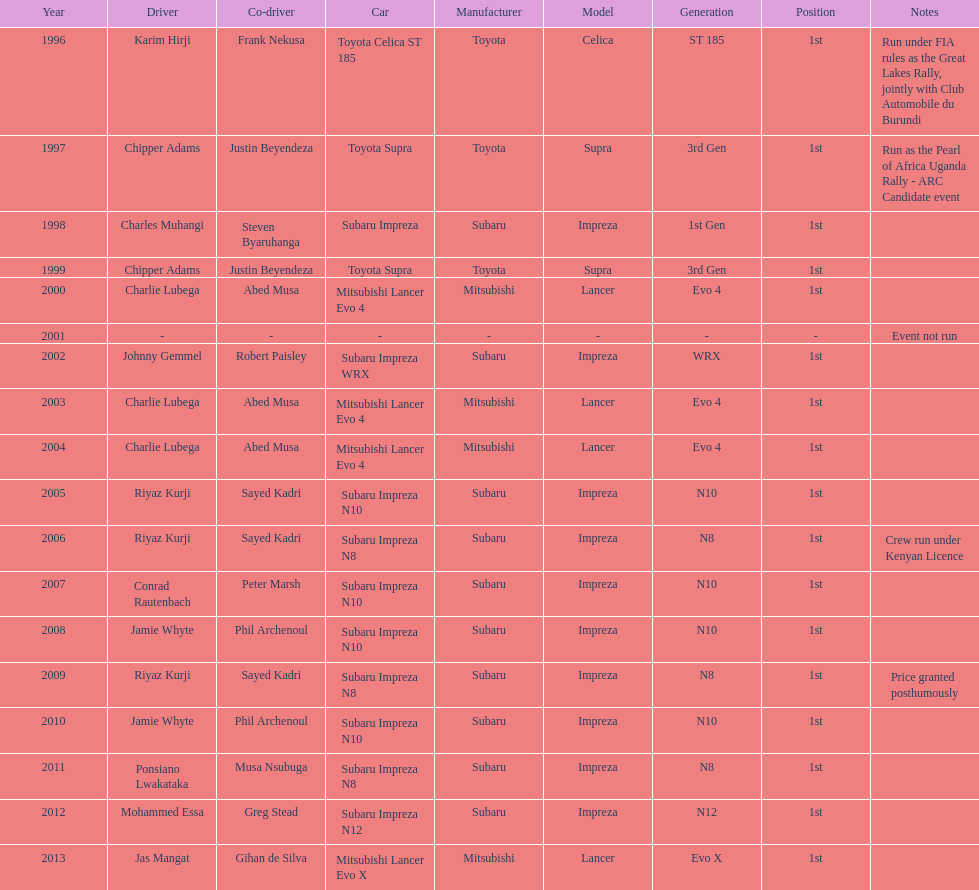Can you parse all the data within this table? {'header': ['Year', 'Driver', 'Co-driver', 'Car', 'Manufacturer', 'Model', 'Generation', 'Position', 'Notes'], 'rows': [['1996', 'Karim Hirji', 'Frank Nekusa', 'Toyota Celica ST 185', 'Toyota', 'Celica', 'ST 185', '1st', 'Run under FIA rules as the Great Lakes Rally, jointly with Club Automobile du Burundi'], ['1997', 'Chipper Adams', 'Justin Beyendeza', 'Toyota Supra', 'Toyota', 'Supra', '3rd Gen', '1st', 'Run as the Pearl of Africa Uganda Rally - ARC Candidate event'], ['1998', 'Charles Muhangi', 'Steven Byaruhanga', 'Subaru Impreza', 'Subaru', 'Impreza', '1st Gen', '1st', ''], ['1999', 'Chipper Adams', 'Justin Beyendeza', 'Toyota Supra', 'Toyota', 'Supra', '3rd Gen', '1st', ''], ['2000', 'Charlie Lubega', 'Abed Musa', 'Mitsubishi Lancer Evo 4', 'Mitsubishi', 'Lancer', 'Evo 4', '1st', ''], ['2001', '-', '-', '-', '-', '-', '-', '-', 'Event not run'], ['2002', 'Johnny Gemmel', 'Robert Paisley', 'Subaru Impreza WRX', 'Subaru', 'Impreza', 'WRX', '1st', ''], ['2003', 'Charlie Lubega', 'Abed Musa', 'Mitsubishi Lancer Evo 4', 'Mitsubishi', 'Lancer', 'Evo 4', '1st', ''], ['2004', 'Charlie Lubega', 'Abed Musa', 'Mitsubishi Lancer Evo 4', 'Mitsubishi', 'Lancer', 'Evo 4', '1st', ''], ['2005', 'Riyaz Kurji', 'Sayed Kadri', 'Subaru Impreza N10', 'Subaru', 'Impreza', 'N10', '1st', ''], ['2006', 'Riyaz Kurji', 'Sayed Kadri', 'Subaru Impreza N8', 'Subaru', 'Impreza', 'N8', '1st', 'Crew run under Kenyan Licence'], ['2007', 'Conrad Rautenbach', 'Peter Marsh', 'Subaru Impreza N10', 'Subaru', 'Impreza', 'N10', '1st', ''], ['2008', 'Jamie Whyte', 'Phil Archenoul', 'Subaru Impreza N10', 'Subaru', 'Impreza', 'N10', '1st', ''], ['2009', 'Riyaz Kurji', 'Sayed Kadri', 'Subaru Impreza N8', 'Subaru', 'Impreza', 'N8', '1st', 'Price granted posthumously'], ['2010', 'Jamie Whyte', 'Phil Archenoul', 'Subaru Impreza N10', 'Subaru', 'Impreza', 'N10', '1st', ''], ['2011', 'Ponsiano Lwakataka', 'Musa Nsubuga', 'Subaru Impreza N8', 'Subaru', 'Impreza', 'N8', '1st', ''], ['2012', 'Mohammed Essa', 'Greg Stead', 'Subaru Impreza N12', 'Subaru', 'Impreza', 'N12', '1st', ''], ['2013', 'Jas Mangat', 'Gihan de Silva', 'Mitsubishi Lancer Evo X', 'Mitsubishi', 'Lancer', 'Evo X', '1st', '']]} How many times was charlie lubega a driver? 3. 